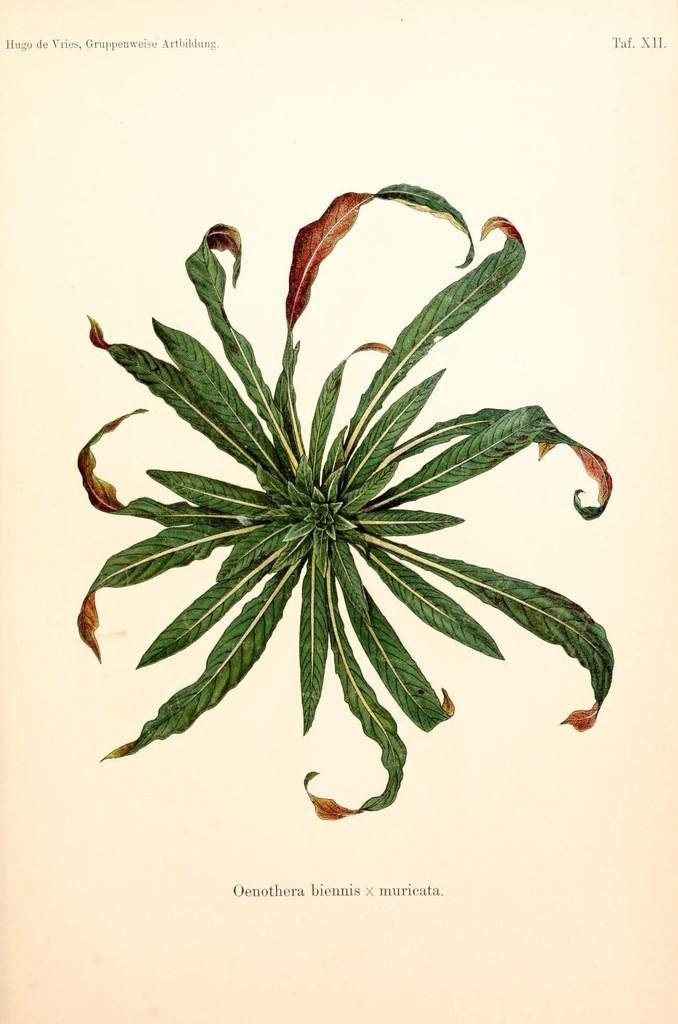What type of natural elements can be seen in the image? There are leaves in the image. What else is present in the image besides the leaves? There is text in the image. Can you describe the main subject of the image? The image appears to be a paper cutting of books. Reasoning: Let's let's think step by step in order to produce the conversation. We start by identifying the natural elements present in the image, which are the leaves. Then, we mention the presence of text in the image. Finally, we describe the main subject of the image, which is a paper cutting of books. Absurd Question/Answer: Where is the toy located in the image? There is no toy present in the image. What type of competition is being held in the image? There is no competition depicted in the image. Where is the toy located in the image? There is no toy present in the image. What type of competition is being held in the image? There is no competition depicted in the image. 